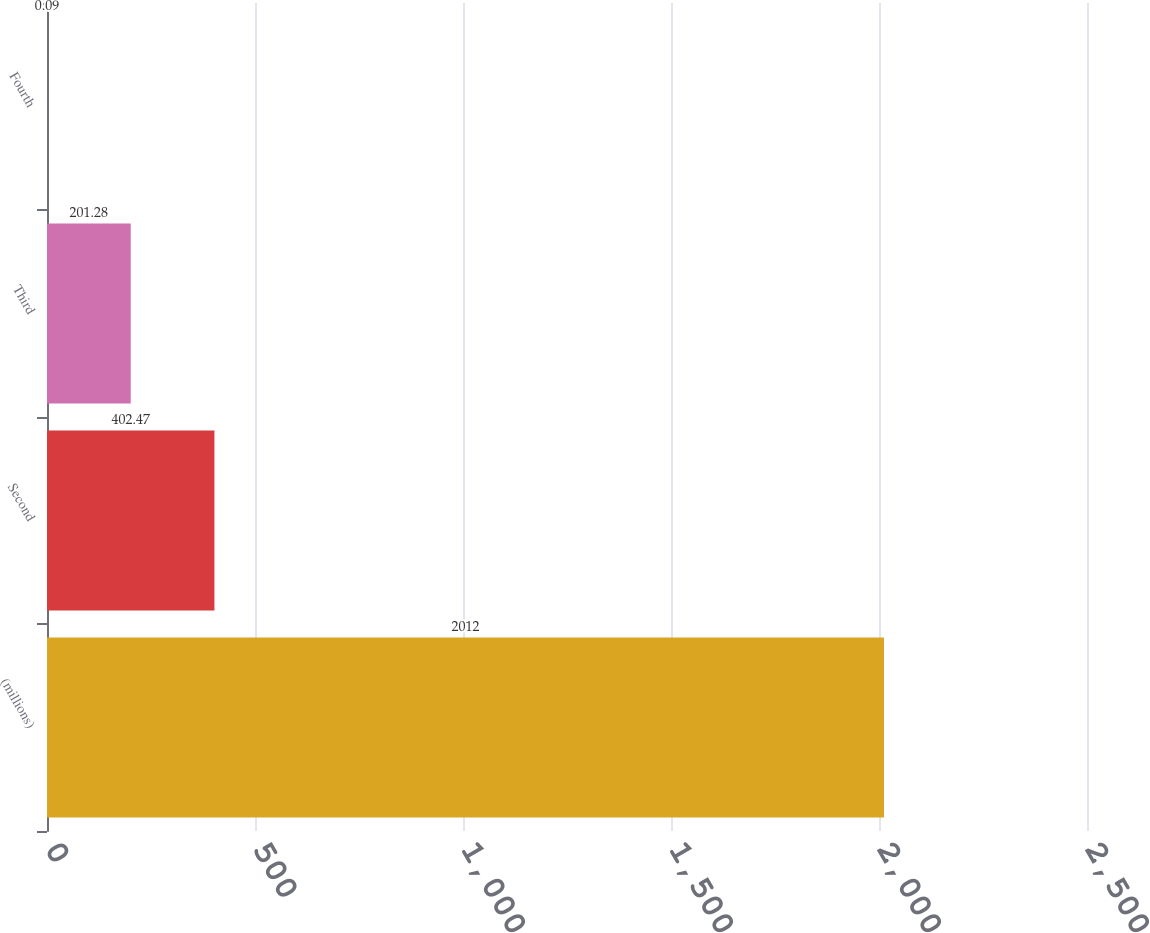Convert chart. <chart><loc_0><loc_0><loc_500><loc_500><bar_chart><fcel>(millions)<fcel>Second<fcel>Third<fcel>Fourth<nl><fcel>2012<fcel>402.47<fcel>201.28<fcel>0.09<nl></chart> 